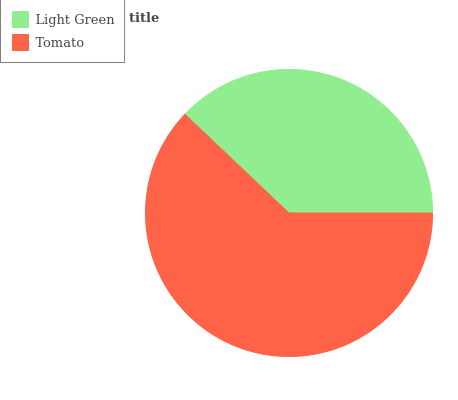Is Light Green the minimum?
Answer yes or no. Yes. Is Tomato the maximum?
Answer yes or no. Yes. Is Tomato the minimum?
Answer yes or no. No. Is Tomato greater than Light Green?
Answer yes or no. Yes. Is Light Green less than Tomato?
Answer yes or no. Yes. Is Light Green greater than Tomato?
Answer yes or no. No. Is Tomato less than Light Green?
Answer yes or no. No. Is Tomato the high median?
Answer yes or no. Yes. Is Light Green the low median?
Answer yes or no. Yes. Is Light Green the high median?
Answer yes or no. No. Is Tomato the low median?
Answer yes or no. No. 